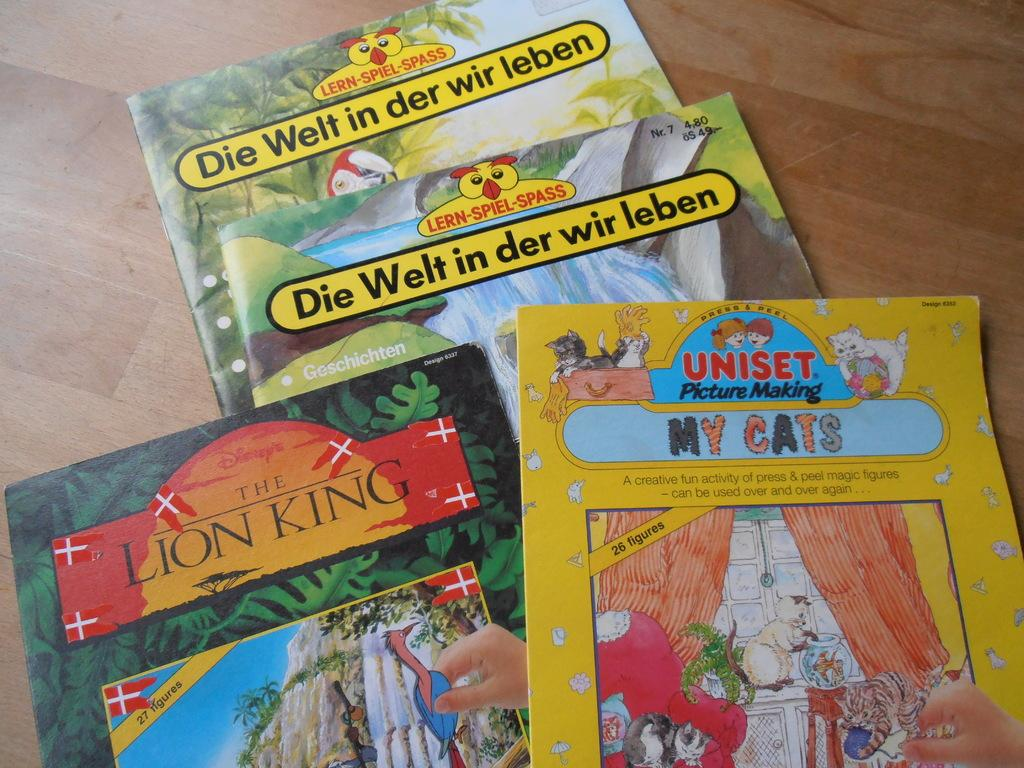<image>
Summarize the visual content of the image. A Lion King book and other books with German titles 